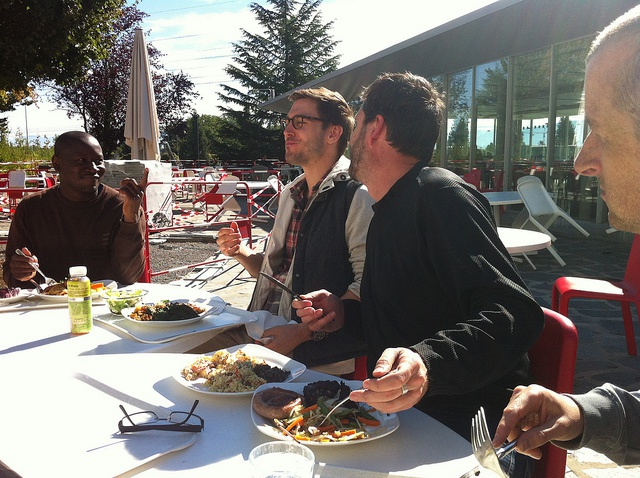Describe the objects in this image and their specific colors. I can see dining table in black, ivory, gray, and darkgray tones, people in black, brown, gray, and ivory tones, people in black, gray, brown, and maroon tones, people in black, gray, maroon, and tan tones, and people in black, maroon, brown, and gray tones in this image. 